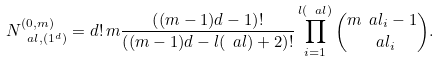<formula> <loc_0><loc_0><loc_500><loc_500>N ^ { ( 0 , m ) } _ { \ a l , ( 1 ^ { d } ) } = d ! \, m \frac { \left ( ( m - 1 ) d - 1 \right ) ! } { \left ( ( m - 1 ) d - l ( \ a l ) + 2 \right ) ! } \prod _ { i = 1 } ^ { l ( \ a l ) } \binom { m \ a l _ { i } - 1 } { \ a l _ { i } } .</formula> 